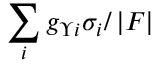Convert formula to latex. <formula><loc_0><loc_0><loc_500><loc_500>\sum _ { i } g _ { \Upsilon i } \sigma _ { i } / \left | F \right |</formula> 